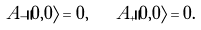Convert formula to latex. <formula><loc_0><loc_0><loc_500><loc_500>A _ { - } \| 0 , 0 \rangle = 0 , \quad A _ { + } \| 0 , 0 \rangle = 0 .</formula> 